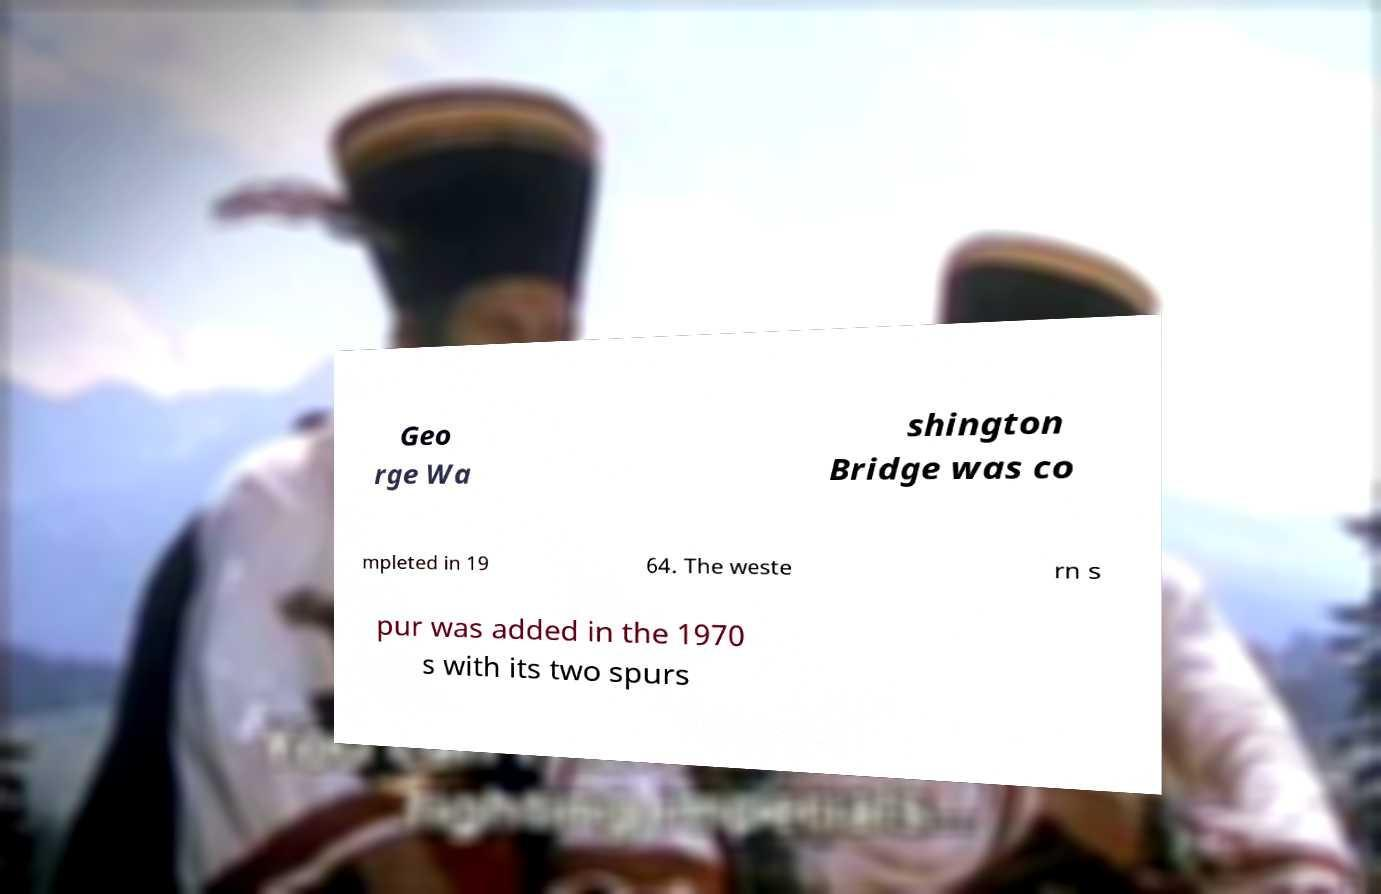Could you extract and type out the text from this image? Geo rge Wa shington Bridge was co mpleted in 19 64. The weste rn s pur was added in the 1970 s with its two spurs 